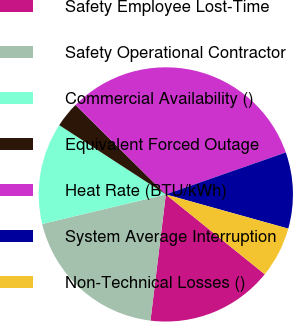Convert chart. <chart><loc_0><loc_0><loc_500><loc_500><pie_chart><fcel>Safety Employee Lost-Time<fcel>Safety Operational Contractor<fcel>Commercial Availability ()<fcel>Equivalent Forced Outage<fcel>Heat Rate (BTU/kWh)<fcel>System Average Interruption<fcel>Non-Technical Losses ()<nl><fcel>16.12%<fcel>19.34%<fcel>12.91%<fcel>3.25%<fcel>32.22%<fcel>9.69%<fcel>6.47%<nl></chart> 